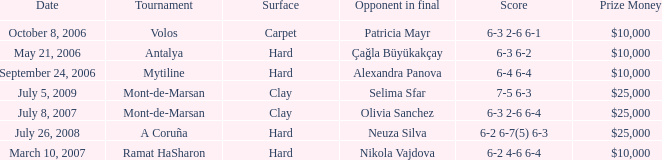What is the score of the match on September 24, 2006? 6-4 6-4. 